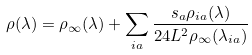<formula> <loc_0><loc_0><loc_500><loc_500>\rho ( \lambda ) = \rho _ { \infty } ( \lambda ) + \sum _ { i a } \frac { s _ { a } \rho _ { i a } ( \lambda ) } { 2 4 L ^ { 2 } \rho _ { \infty } ( \lambda _ { i a } ) }</formula> 